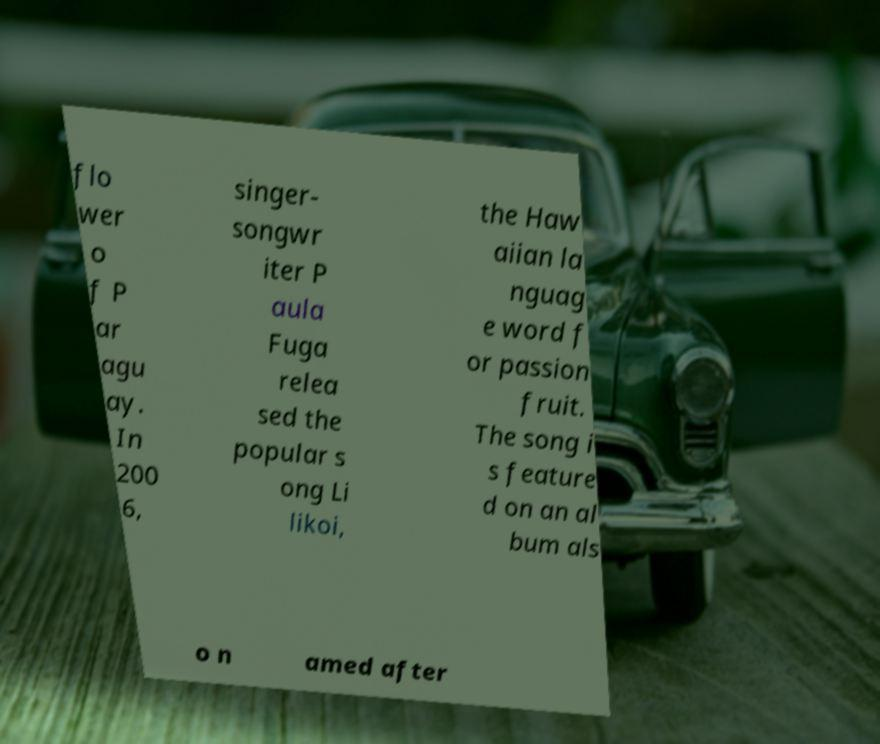For documentation purposes, I need the text within this image transcribed. Could you provide that? flo wer o f P ar agu ay. In 200 6, singer- songwr iter P aula Fuga relea sed the popular s ong Li likoi, the Haw aiian la nguag e word f or passion fruit. The song i s feature d on an al bum als o n amed after 